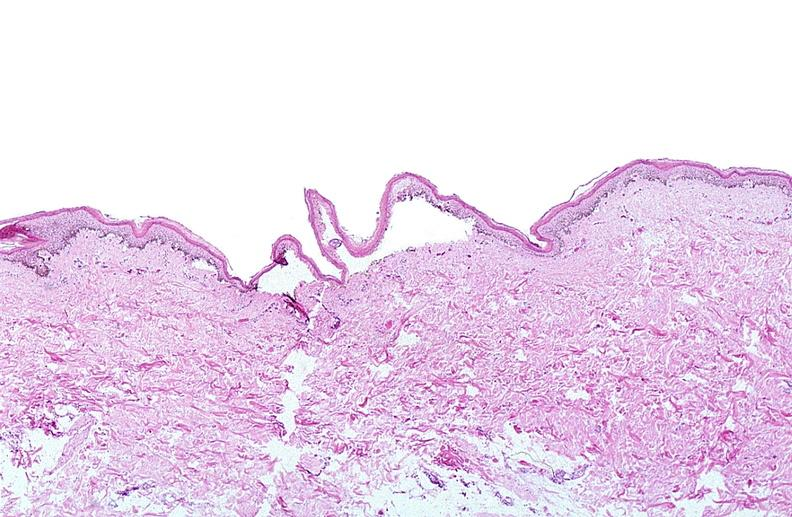does this image show thermal burned skin?
Answer the question using a single word or phrase. Yes 